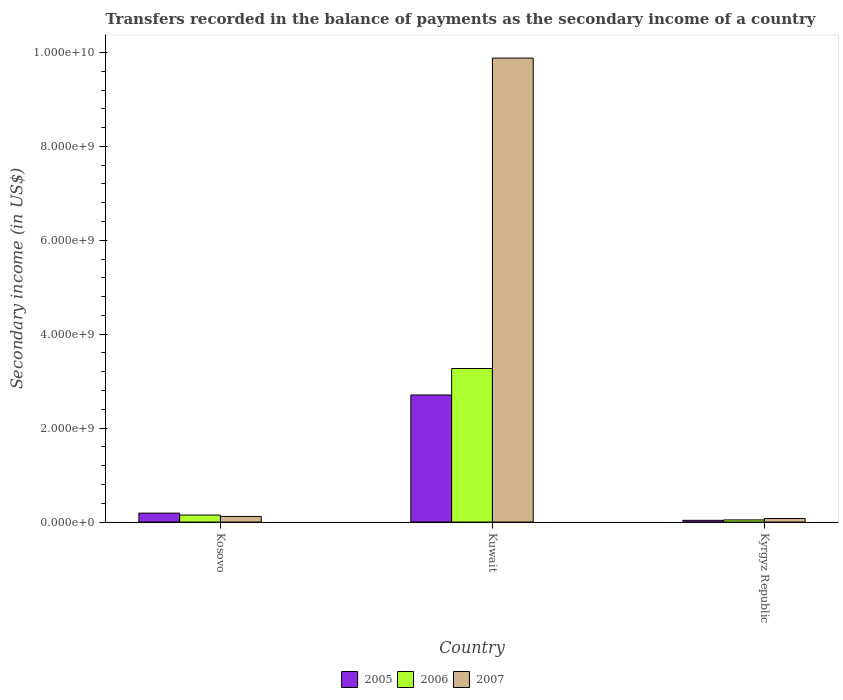How many different coloured bars are there?
Keep it short and to the point. 3. Are the number of bars on each tick of the X-axis equal?
Provide a succinct answer. Yes. How many bars are there on the 2nd tick from the left?
Offer a very short reply. 3. How many bars are there on the 1st tick from the right?
Offer a terse response. 3. What is the label of the 2nd group of bars from the left?
Your answer should be compact. Kuwait. What is the secondary income of in 2007 in Kyrgyz Republic?
Your answer should be compact. 7.56e+07. Across all countries, what is the maximum secondary income of in 2006?
Offer a very short reply. 3.27e+09. Across all countries, what is the minimum secondary income of in 2007?
Ensure brevity in your answer.  7.56e+07. In which country was the secondary income of in 2005 maximum?
Make the answer very short. Kuwait. In which country was the secondary income of in 2007 minimum?
Provide a succinct answer. Kyrgyz Republic. What is the total secondary income of in 2007 in the graph?
Offer a terse response. 1.01e+1. What is the difference between the secondary income of in 2007 in Kosovo and that in Kuwait?
Provide a succinct answer. -9.76e+09. What is the difference between the secondary income of in 2006 in Kyrgyz Republic and the secondary income of in 2007 in Kosovo?
Your answer should be compact. -7.36e+07. What is the average secondary income of in 2006 per country?
Your response must be concise. 1.15e+09. What is the difference between the secondary income of of/in 2006 and secondary income of of/in 2005 in Kosovo?
Provide a succinct answer. -4.11e+07. What is the ratio of the secondary income of in 2007 in Kosovo to that in Kyrgyz Republic?
Keep it short and to the point. 1.57. Is the secondary income of in 2007 in Kosovo less than that in Kuwait?
Your answer should be very brief. Yes. What is the difference between the highest and the second highest secondary income of in 2005?
Your response must be concise. -2.52e+09. What is the difference between the highest and the lowest secondary income of in 2007?
Offer a very short reply. 9.80e+09. What does the 3rd bar from the right in Kuwait represents?
Provide a succinct answer. 2005. Are all the bars in the graph horizontal?
Keep it short and to the point. No. What is the difference between two consecutive major ticks on the Y-axis?
Ensure brevity in your answer.  2.00e+09. Are the values on the major ticks of Y-axis written in scientific E-notation?
Your answer should be very brief. Yes. Where does the legend appear in the graph?
Provide a succinct answer. Bottom center. How many legend labels are there?
Your answer should be compact. 3. How are the legend labels stacked?
Your answer should be very brief. Horizontal. What is the title of the graph?
Offer a terse response. Transfers recorded in the balance of payments as the secondary income of a country. Does "1965" appear as one of the legend labels in the graph?
Your answer should be very brief. No. What is the label or title of the X-axis?
Offer a very short reply. Country. What is the label or title of the Y-axis?
Your answer should be compact. Secondary income (in US$). What is the Secondary income (in US$) of 2005 in Kosovo?
Offer a very short reply. 1.90e+08. What is the Secondary income (in US$) in 2006 in Kosovo?
Make the answer very short. 1.48e+08. What is the Secondary income (in US$) in 2007 in Kosovo?
Offer a terse response. 1.19e+08. What is the Secondary income (in US$) in 2005 in Kuwait?
Give a very brief answer. 2.71e+09. What is the Secondary income (in US$) of 2006 in Kuwait?
Give a very brief answer. 3.27e+09. What is the Secondary income (in US$) of 2007 in Kuwait?
Provide a succinct answer. 9.88e+09. What is the Secondary income (in US$) in 2005 in Kyrgyz Republic?
Your response must be concise. 3.63e+07. What is the Secondary income (in US$) of 2006 in Kyrgyz Republic?
Your answer should be compact. 4.53e+07. What is the Secondary income (in US$) of 2007 in Kyrgyz Republic?
Your answer should be compact. 7.56e+07. Across all countries, what is the maximum Secondary income (in US$) in 2005?
Offer a very short reply. 2.71e+09. Across all countries, what is the maximum Secondary income (in US$) in 2006?
Offer a very short reply. 3.27e+09. Across all countries, what is the maximum Secondary income (in US$) of 2007?
Your answer should be very brief. 9.88e+09. Across all countries, what is the minimum Secondary income (in US$) of 2005?
Keep it short and to the point. 3.63e+07. Across all countries, what is the minimum Secondary income (in US$) of 2006?
Give a very brief answer. 4.53e+07. Across all countries, what is the minimum Secondary income (in US$) of 2007?
Offer a very short reply. 7.56e+07. What is the total Secondary income (in US$) of 2005 in the graph?
Provide a short and direct response. 2.93e+09. What is the total Secondary income (in US$) in 2006 in the graph?
Offer a very short reply. 3.46e+09. What is the total Secondary income (in US$) of 2007 in the graph?
Keep it short and to the point. 1.01e+1. What is the difference between the Secondary income (in US$) of 2005 in Kosovo and that in Kuwait?
Provide a succinct answer. -2.52e+09. What is the difference between the Secondary income (in US$) in 2006 in Kosovo and that in Kuwait?
Make the answer very short. -3.12e+09. What is the difference between the Secondary income (in US$) in 2007 in Kosovo and that in Kuwait?
Offer a very short reply. -9.76e+09. What is the difference between the Secondary income (in US$) in 2005 in Kosovo and that in Kyrgyz Republic?
Your answer should be very brief. 1.53e+08. What is the difference between the Secondary income (in US$) of 2006 in Kosovo and that in Kyrgyz Republic?
Your answer should be very brief. 1.03e+08. What is the difference between the Secondary income (in US$) in 2007 in Kosovo and that in Kyrgyz Republic?
Your response must be concise. 4.33e+07. What is the difference between the Secondary income (in US$) in 2005 in Kuwait and that in Kyrgyz Republic?
Provide a short and direct response. 2.67e+09. What is the difference between the Secondary income (in US$) of 2006 in Kuwait and that in Kyrgyz Republic?
Your response must be concise. 3.22e+09. What is the difference between the Secondary income (in US$) of 2007 in Kuwait and that in Kyrgyz Republic?
Your answer should be very brief. 9.80e+09. What is the difference between the Secondary income (in US$) in 2005 in Kosovo and the Secondary income (in US$) in 2006 in Kuwait?
Offer a terse response. -3.08e+09. What is the difference between the Secondary income (in US$) in 2005 in Kosovo and the Secondary income (in US$) in 2007 in Kuwait?
Provide a succinct answer. -9.69e+09. What is the difference between the Secondary income (in US$) in 2006 in Kosovo and the Secondary income (in US$) in 2007 in Kuwait?
Your response must be concise. -9.73e+09. What is the difference between the Secondary income (in US$) in 2005 in Kosovo and the Secondary income (in US$) in 2006 in Kyrgyz Republic?
Offer a terse response. 1.44e+08. What is the difference between the Secondary income (in US$) in 2005 in Kosovo and the Secondary income (in US$) in 2007 in Kyrgyz Republic?
Provide a short and direct response. 1.14e+08. What is the difference between the Secondary income (in US$) of 2006 in Kosovo and the Secondary income (in US$) of 2007 in Kyrgyz Republic?
Your answer should be compact. 7.29e+07. What is the difference between the Secondary income (in US$) of 2005 in Kuwait and the Secondary income (in US$) of 2006 in Kyrgyz Republic?
Keep it short and to the point. 2.66e+09. What is the difference between the Secondary income (in US$) in 2005 in Kuwait and the Secondary income (in US$) in 2007 in Kyrgyz Republic?
Ensure brevity in your answer.  2.63e+09. What is the difference between the Secondary income (in US$) of 2006 in Kuwait and the Secondary income (in US$) of 2007 in Kyrgyz Republic?
Give a very brief answer. 3.19e+09. What is the average Secondary income (in US$) in 2005 per country?
Provide a succinct answer. 9.77e+08. What is the average Secondary income (in US$) in 2006 per country?
Offer a terse response. 1.15e+09. What is the average Secondary income (in US$) in 2007 per country?
Provide a succinct answer. 3.36e+09. What is the difference between the Secondary income (in US$) of 2005 and Secondary income (in US$) of 2006 in Kosovo?
Provide a short and direct response. 4.11e+07. What is the difference between the Secondary income (in US$) in 2005 and Secondary income (in US$) in 2007 in Kosovo?
Provide a short and direct response. 7.07e+07. What is the difference between the Secondary income (in US$) of 2006 and Secondary income (in US$) of 2007 in Kosovo?
Give a very brief answer. 2.97e+07. What is the difference between the Secondary income (in US$) in 2005 and Secondary income (in US$) in 2006 in Kuwait?
Offer a very short reply. -5.64e+08. What is the difference between the Secondary income (in US$) in 2005 and Secondary income (in US$) in 2007 in Kuwait?
Offer a very short reply. -7.17e+09. What is the difference between the Secondary income (in US$) in 2006 and Secondary income (in US$) in 2007 in Kuwait?
Provide a succinct answer. -6.61e+09. What is the difference between the Secondary income (in US$) in 2005 and Secondary income (in US$) in 2006 in Kyrgyz Republic?
Your answer should be compact. -8.99e+06. What is the difference between the Secondary income (in US$) in 2005 and Secondary income (in US$) in 2007 in Kyrgyz Republic?
Offer a very short reply. -3.93e+07. What is the difference between the Secondary income (in US$) in 2006 and Secondary income (in US$) in 2007 in Kyrgyz Republic?
Keep it short and to the point. -3.03e+07. What is the ratio of the Secondary income (in US$) in 2005 in Kosovo to that in Kuwait?
Keep it short and to the point. 0.07. What is the ratio of the Secondary income (in US$) in 2006 in Kosovo to that in Kuwait?
Keep it short and to the point. 0.05. What is the ratio of the Secondary income (in US$) of 2007 in Kosovo to that in Kuwait?
Provide a succinct answer. 0.01. What is the ratio of the Secondary income (in US$) of 2005 in Kosovo to that in Kyrgyz Republic?
Offer a very short reply. 5.23. What is the ratio of the Secondary income (in US$) in 2006 in Kosovo to that in Kyrgyz Republic?
Offer a very short reply. 3.28. What is the ratio of the Secondary income (in US$) of 2007 in Kosovo to that in Kyrgyz Republic?
Make the answer very short. 1.57. What is the ratio of the Secondary income (in US$) of 2005 in Kuwait to that in Kyrgyz Republic?
Offer a very short reply. 74.58. What is the ratio of the Secondary income (in US$) of 2006 in Kuwait to that in Kyrgyz Republic?
Give a very brief answer. 72.23. What is the ratio of the Secondary income (in US$) of 2007 in Kuwait to that in Kyrgyz Republic?
Your answer should be very brief. 130.76. What is the difference between the highest and the second highest Secondary income (in US$) of 2005?
Your response must be concise. 2.52e+09. What is the difference between the highest and the second highest Secondary income (in US$) of 2006?
Make the answer very short. 3.12e+09. What is the difference between the highest and the second highest Secondary income (in US$) in 2007?
Provide a succinct answer. 9.76e+09. What is the difference between the highest and the lowest Secondary income (in US$) in 2005?
Offer a terse response. 2.67e+09. What is the difference between the highest and the lowest Secondary income (in US$) in 2006?
Make the answer very short. 3.22e+09. What is the difference between the highest and the lowest Secondary income (in US$) of 2007?
Your response must be concise. 9.80e+09. 